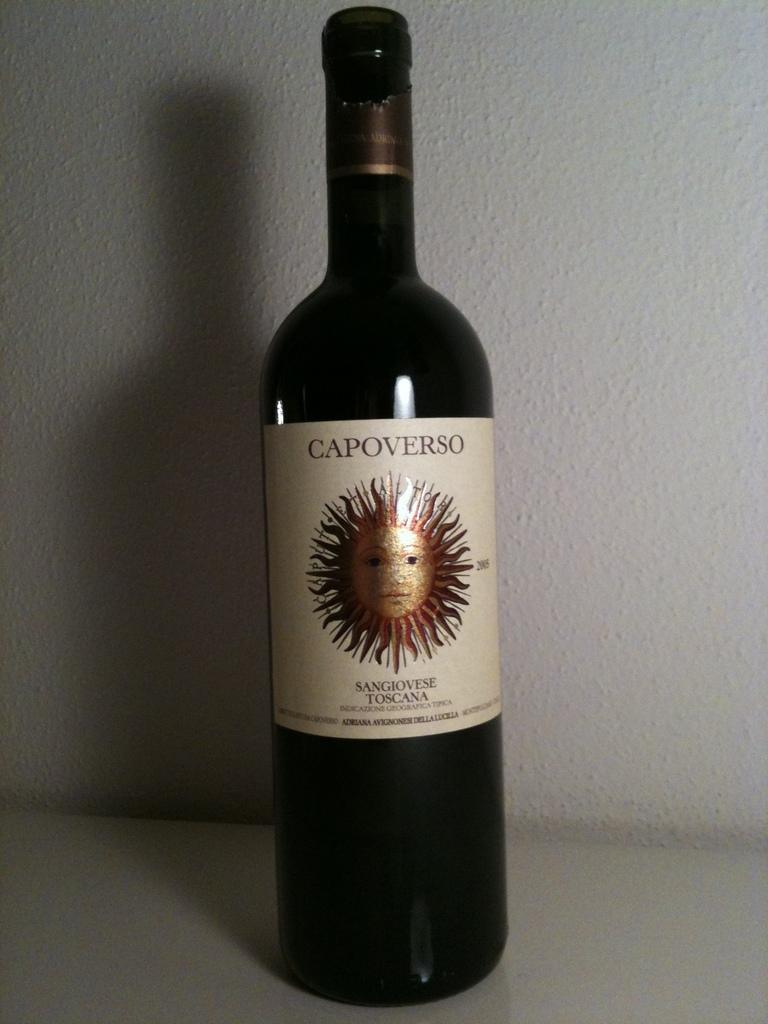Provide a one-sentence caption for the provided image. A bottle of Capoverso wine is in front of a white wall. 